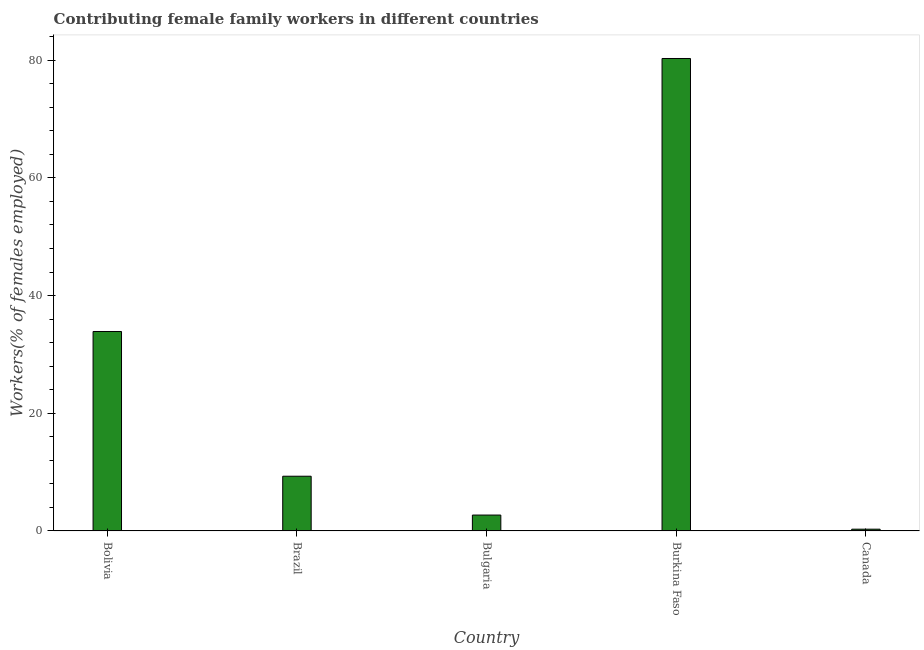Does the graph contain grids?
Keep it short and to the point. No. What is the title of the graph?
Your answer should be compact. Contributing female family workers in different countries. What is the label or title of the Y-axis?
Ensure brevity in your answer.  Workers(% of females employed). What is the contributing female family workers in Bolivia?
Your response must be concise. 33.9. Across all countries, what is the maximum contributing female family workers?
Ensure brevity in your answer.  80.3. Across all countries, what is the minimum contributing female family workers?
Offer a very short reply. 0.3. In which country was the contributing female family workers maximum?
Your answer should be compact. Burkina Faso. In which country was the contributing female family workers minimum?
Keep it short and to the point. Canada. What is the sum of the contributing female family workers?
Provide a short and direct response. 126.5. What is the difference between the contributing female family workers in Bolivia and Brazil?
Your answer should be very brief. 24.6. What is the average contributing female family workers per country?
Your response must be concise. 25.3. What is the median contributing female family workers?
Ensure brevity in your answer.  9.3. In how many countries, is the contributing female family workers greater than 12 %?
Offer a terse response. 2. What is the ratio of the contributing female family workers in Bolivia to that in Canada?
Your answer should be compact. 113. What is the difference between the highest and the second highest contributing female family workers?
Your answer should be compact. 46.4. Is the sum of the contributing female family workers in Bolivia and Brazil greater than the maximum contributing female family workers across all countries?
Ensure brevity in your answer.  No. What is the difference between the highest and the lowest contributing female family workers?
Offer a terse response. 80. In how many countries, is the contributing female family workers greater than the average contributing female family workers taken over all countries?
Offer a very short reply. 2. How many bars are there?
Give a very brief answer. 5. Are all the bars in the graph horizontal?
Provide a succinct answer. No. Are the values on the major ticks of Y-axis written in scientific E-notation?
Provide a short and direct response. No. What is the Workers(% of females employed) in Bolivia?
Offer a terse response. 33.9. What is the Workers(% of females employed) of Brazil?
Give a very brief answer. 9.3. What is the Workers(% of females employed) in Bulgaria?
Give a very brief answer. 2.7. What is the Workers(% of females employed) of Burkina Faso?
Your answer should be very brief. 80.3. What is the Workers(% of females employed) of Canada?
Give a very brief answer. 0.3. What is the difference between the Workers(% of females employed) in Bolivia and Brazil?
Your response must be concise. 24.6. What is the difference between the Workers(% of females employed) in Bolivia and Bulgaria?
Keep it short and to the point. 31.2. What is the difference between the Workers(% of females employed) in Bolivia and Burkina Faso?
Your response must be concise. -46.4. What is the difference between the Workers(% of females employed) in Bolivia and Canada?
Give a very brief answer. 33.6. What is the difference between the Workers(% of females employed) in Brazil and Bulgaria?
Give a very brief answer. 6.6. What is the difference between the Workers(% of females employed) in Brazil and Burkina Faso?
Provide a short and direct response. -71. What is the difference between the Workers(% of females employed) in Brazil and Canada?
Provide a succinct answer. 9. What is the difference between the Workers(% of females employed) in Bulgaria and Burkina Faso?
Make the answer very short. -77.6. What is the difference between the Workers(% of females employed) in Burkina Faso and Canada?
Ensure brevity in your answer.  80. What is the ratio of the Workers(% of females employed) in Bolivia to that in Brazil?
Keep it short and to the point. 3.65. What is the ratio of the Workers(% of females employed) in Bolivia to that in Bulgaria?
Keep it short and to the point. 12.56. What is the ratio of the Workers(% of females employed) in Bolivia to that in Burkina Faso?
Your answer should be very brief. 0.42. What is the ratio of the Workers(% of females employed) in Bolivia to that in Canada?
Provide a succinct answer. 113. What is the ratio of the Workers(% of females employed) in Brazil to that in Bulgaria?
Provide a succinct answer. 3.44. What is the ratio of the Workers(% of females employed) in Brazil to that in Burkina Faso?
Provide a succinct answer. 0.12. What is the ratio of the Workers(% of females employed) in Bulgaria to that in Burkina Faso?
Give a very brief answer. 0.03. What is the ratio of the Workers(% of females employed) in Bulgaria to that in Canada?
Offer a very short reply. 9. What is the ratio of the Workers(% of females employed) in Burkina Faso to that in Canada?
Make the answer very short. 267.67. 